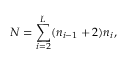<formula> <loc_0><loc_0><loc_500><loc_500>N = \sum _ { i = 2 } ^ { L } ( n _ { i - 1 } + 2 ) n _ { i } ,</formula> 